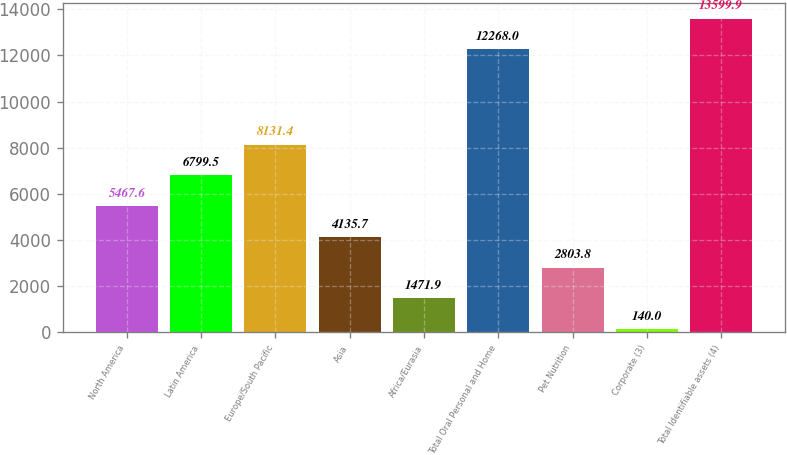Convert chart. <chart><loc_0><loc_0><loc_500><loc_500><bar_chart><fcel>North America<fcel>Latin America<fcel>Europe/South Pacific<fcel>Asia<fcel>Africa/Eurasia<fcel>Total Oral Personal and Home<fcel>Pet Nutrition<fcel>Corporate (3)<fcel>Total Identifiable assets (4)<nl><fcel>5467.6<fcel>6799.5<fcel>8131.4<fcel>4135.7<fcel>1471.9<fcel>12268<fcel>2803.8<fcel>140<fcel>13599.9<nl></chart> 